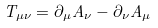Convert formula to latex. <formula><loc_0><loc_0><loc_500><loc_500>T _ { \mu \nu } = \partial _ { \mu } A _ { \nu } - \partial _ { \nu } A _ { \mu }</formula> 